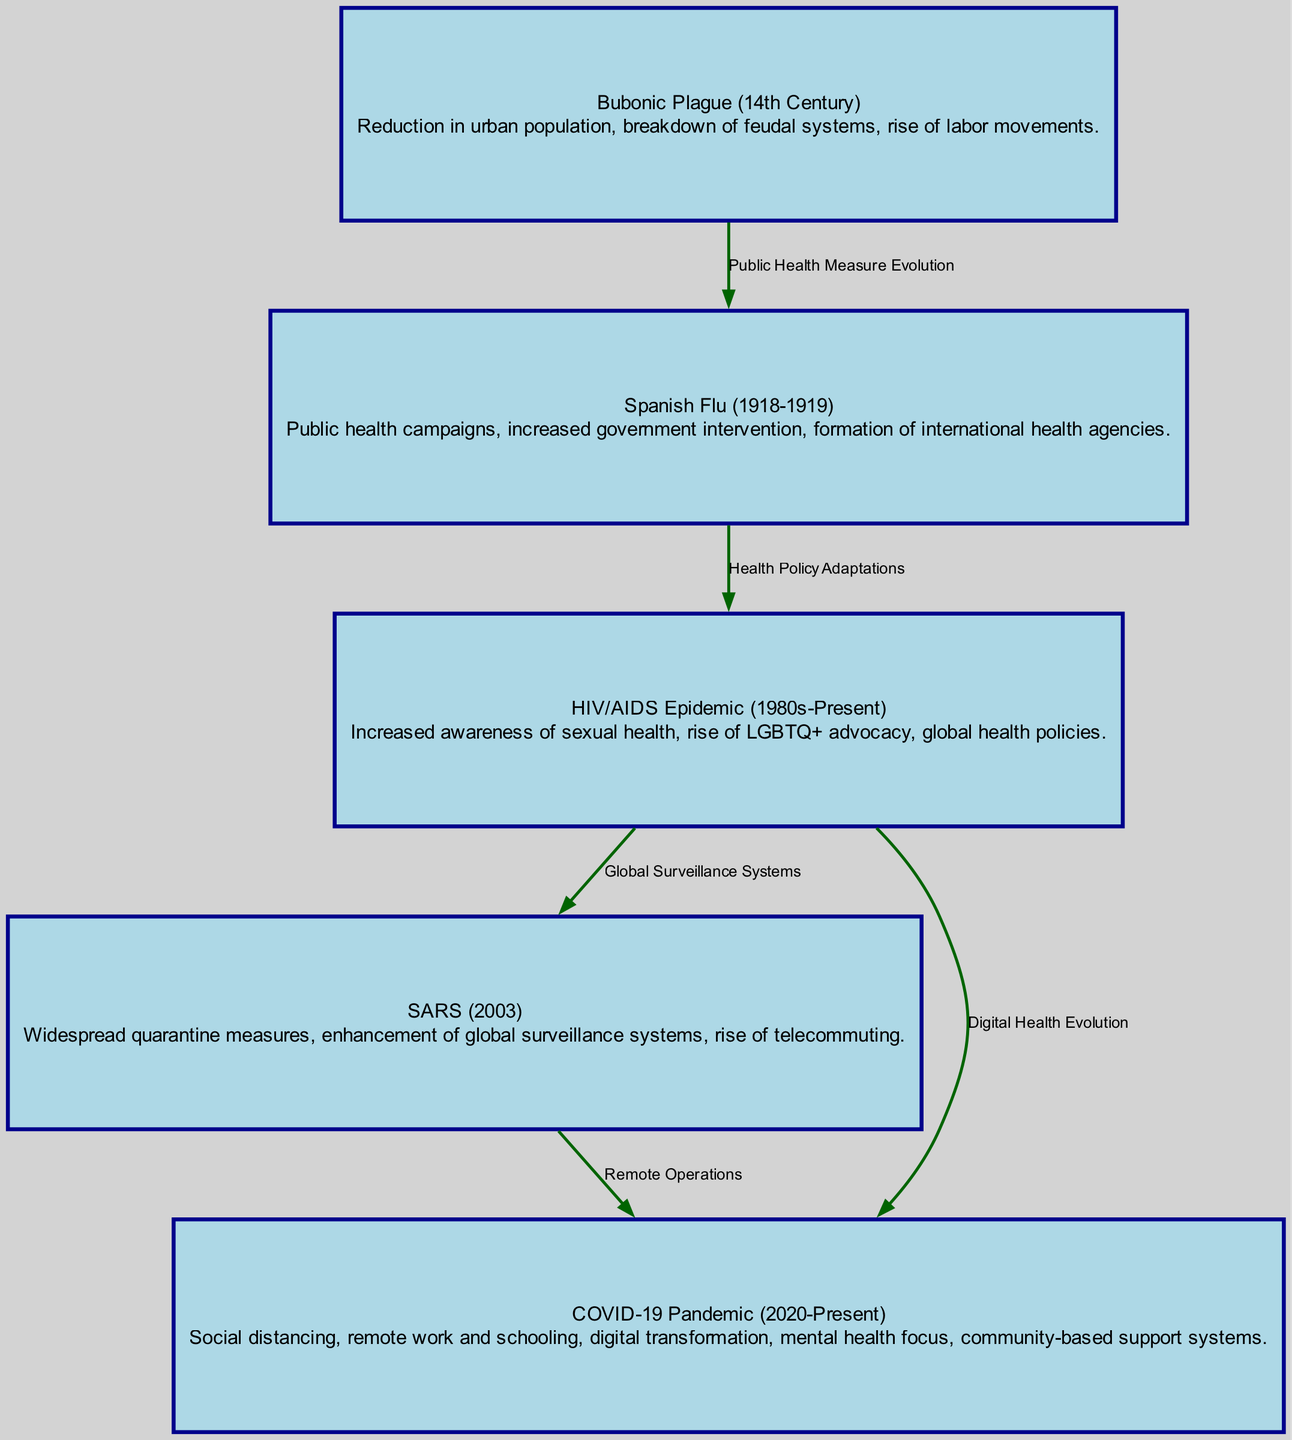What's the total number of nodes in the diagram? The diagram contains six entries categorized as nodes, including historical pandemics and their impacts. We can count them: Bubonic Plague, Spanish Flu, HIV/AIDS Epidemic, SARS, and COVID-19 Pandemic. This adds up to five nodes.
Answer: 5 What health measure connected the Bubonic Plague to the Spanish Flu? The edge labeled "Public Health Measure Evolution" illustrates the relationship between these two nodes, indicating that public health measures were a significant connection during the timeline.
Answer: Public Health Measure Evolution Which pandemic introduced digital health evolution? The edge leading from the HIV/AIDS Epidemic to the COVID-19 Pandemic is labeled "Digital Health Evolution," indicating that it was during the timeline of the HIV/AIDS Epidemic that the foundations for digital health advancements began.
Answer: COVID-19 Pandemic Which pandemic motivated the rise of telecommuting? The edge labeled "Remote Operations" connects SARS with the COVID-19 Pandemic, showing that the SARS outbreak was associated with the emergence of telecommuting practices to maintain social interaction while minimizing disease spread.
Answer: SARS What change occurred as a response to the HIV/AIDS Epidemic? The edge connecting the HIV/AIDS Epidemic to SARS is labeled "Global Surveillance Systems," indicating that one of the adaptations made in response to the HIV/AIDS Epidemic was an enhancement of surveillance systems on a global scale to prevent health crises.
Answer: Global Surveillance Systems What was a major adaptation observed during the COVID-19 Pandemic? The description for the COVID-19 Pandemic node indicates multiple adaptations, such as remote work and schooling, social distancing, and a mental health focus. This highlights significant changes in societal behavior in response to the pandemic.
Answer: Remote work and schooling How did the community behaviors shift from the Bubonic Plague to the Spanish Flu? The transition is marked by an increase in public health campaigns after the Bubonic Plague, which led to more structured community behavior and a focus on public health, illustrating broader societal awareness and intervention strategies in the following pandemic.
Answer: Public health campaigns What role did government intervention play during the Spanish Flu? The node description for the Spanish Flu notes increased government intervention as a key response to the public health crisis, indicating a shift in societal structures towards more organized health responses.
Answer: Increased government intervention What is the most recent pandemic illustrated in this diagram? The last node presented is the COVID-19 Pandemic, which is denoted as occurring from 2020 to the present, making it the most current event highlighted in the diagram.
Answer: COVID-19 Pandemic 